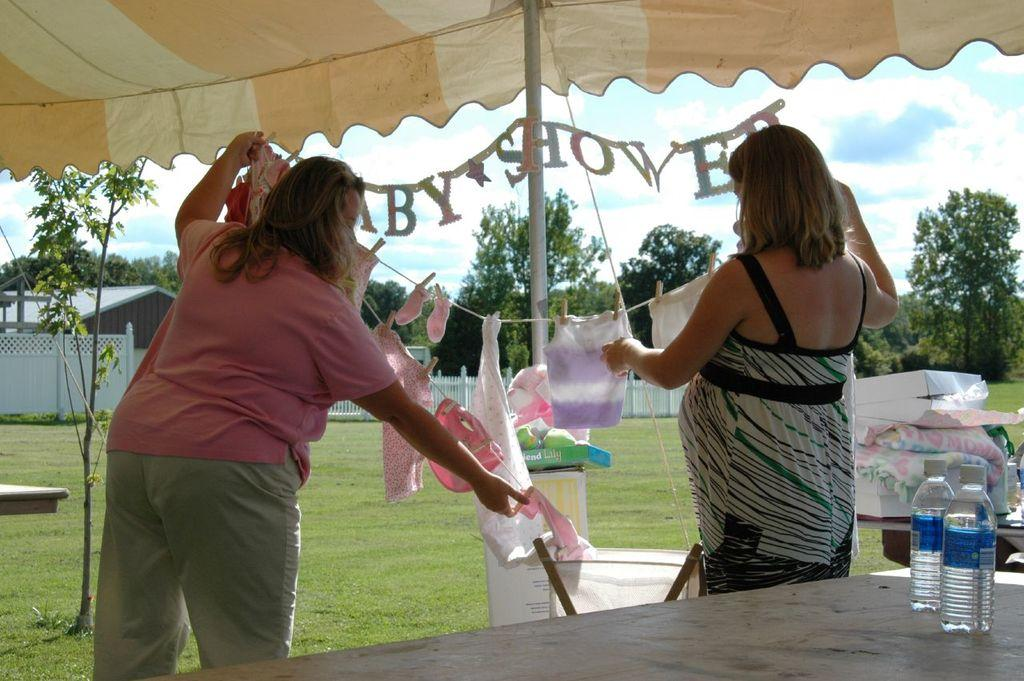How many women are present in the image? There are two women in the image. What are the women doing in the image? The women are standing. What can be seen in the background of the image? There are trees in the background of the image. What is the condition of the sky in the image? The sky is clear in the image. What type of society can be seen in the image? There is no reference to a society in the image; it features two women standing with trees in the background. Are the women swimming in the image? No, the women are standing, not swimming, in the image. 